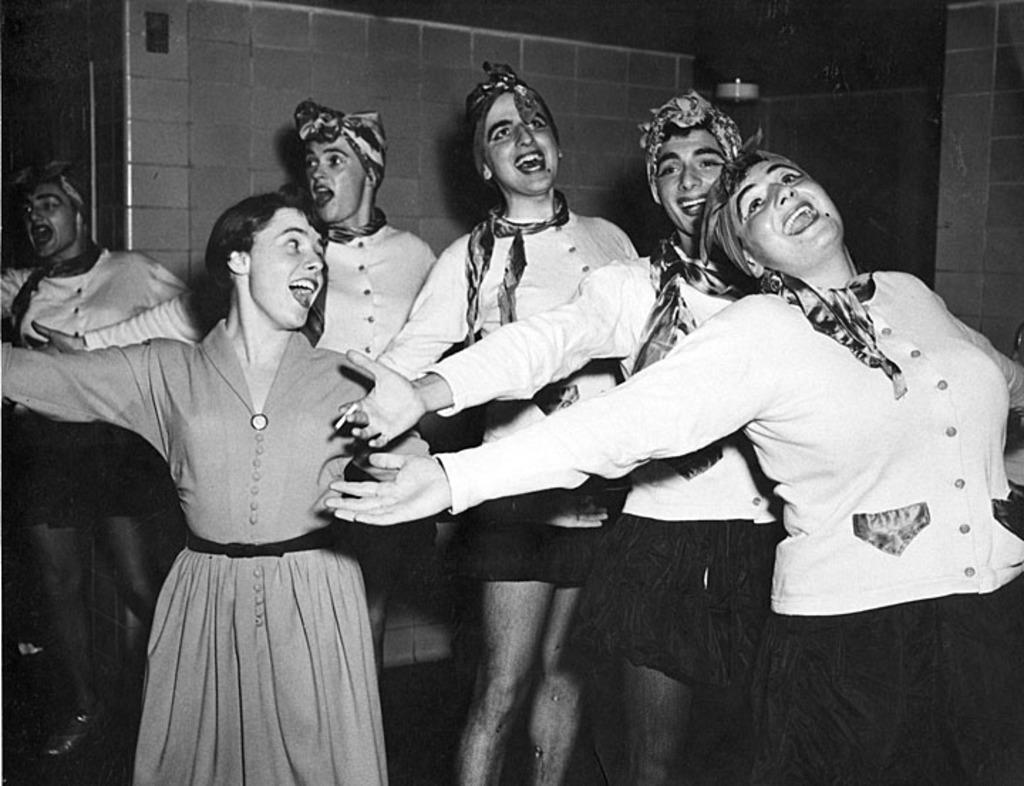Could you give a brief overview of what you see in this image? In this image there is a group of people and the wall. 